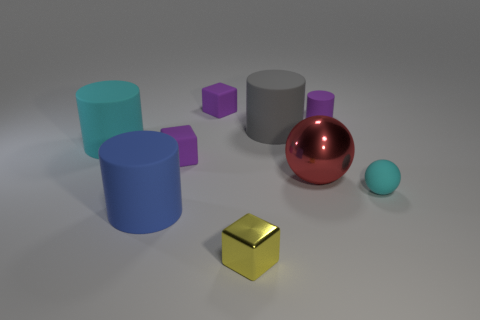Subtract all tiny purple cubes. How many cubes are left? 1 Subtract all blocks. How many objects are left? 6 Subtract all green balls. How many purple cubes are left? 2 Subtract all yellow cubes. How many cubes are left? 2 Subtract all cyan balls. Subtract all brown cylinders. How many balls are left? 1 Subtract all tiny rubber cylinders. Subtract all large cyan matte cylinders. How many objects are left? 7 Add 6 small cyan things. How many small cyan things are left? 7 Add 9 small green metallic cubes. How many small green metallic cubes exist? 9 Subtract 1 purple cylinders. How many objects are left? 8 Subtract 1 blocks. How many blocks are left? 2 